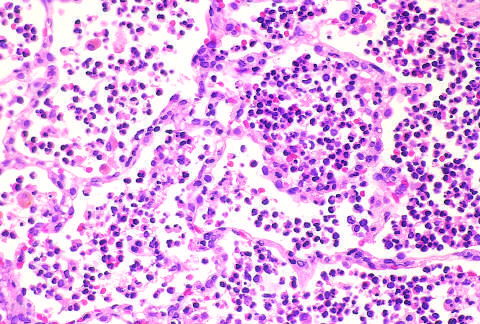have fibrin nets not yet formed?
Answer the question using a single word or phrase. Yes 